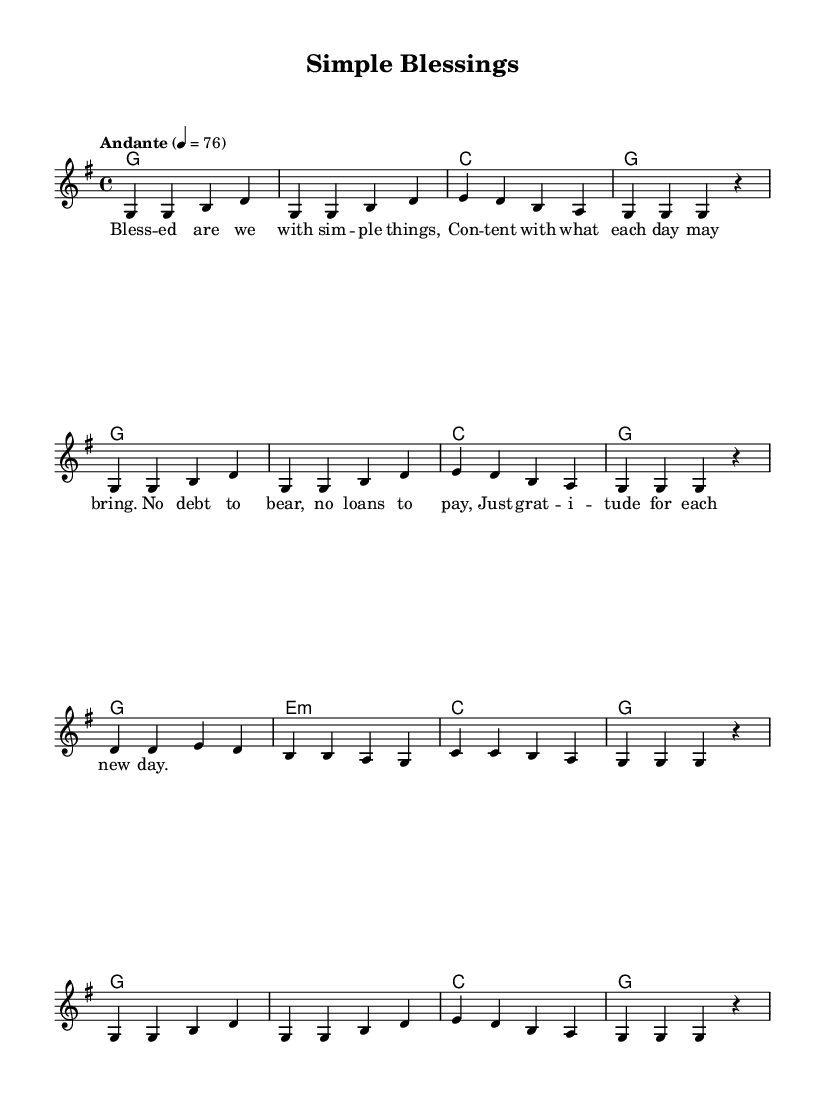What is the key signature of this music? The key signature is indicated at the beginning of the music. In this case, it shows one sharp, which corresponds to G major.
Answer: G major What is the time signature of this music? The time signature appears at the beginning of the piece and is shown as 4/4. This indicates there are four beats in each measure.
Answer: 4/4 What is the tempo marking for this music? The tempo marking, which indicates the speed of the music, is noted as "Andante" with a metronome marking of 76. This suggests a moderately slow pace.
Answer: Andante, 76 How many measures are in the melody? To find the number of measures, count the vertical lines that separate the groups of notes in the melody. In this case, there are a total of 12 measures.
Answer: 12 What is the main theme of the lyrics? The lyrics suggest a theme of simplicity and contentment, highlighting gratitude for each new day without the burden of debt. The repeated phrases emphasize this theme.
Answer: Simplicity and contentment What chord is played in the third measure of the harmonies? The third measure indicates the chord to be played with the identifier 'c', meaning it is a C major chord.
Answer: C major What message do the lyrics convey about debt? The lyrics explicitly state, "No debt to bear, no loans to pay," expressing a positive view towards living without financial burdens.
Answer: No debt 